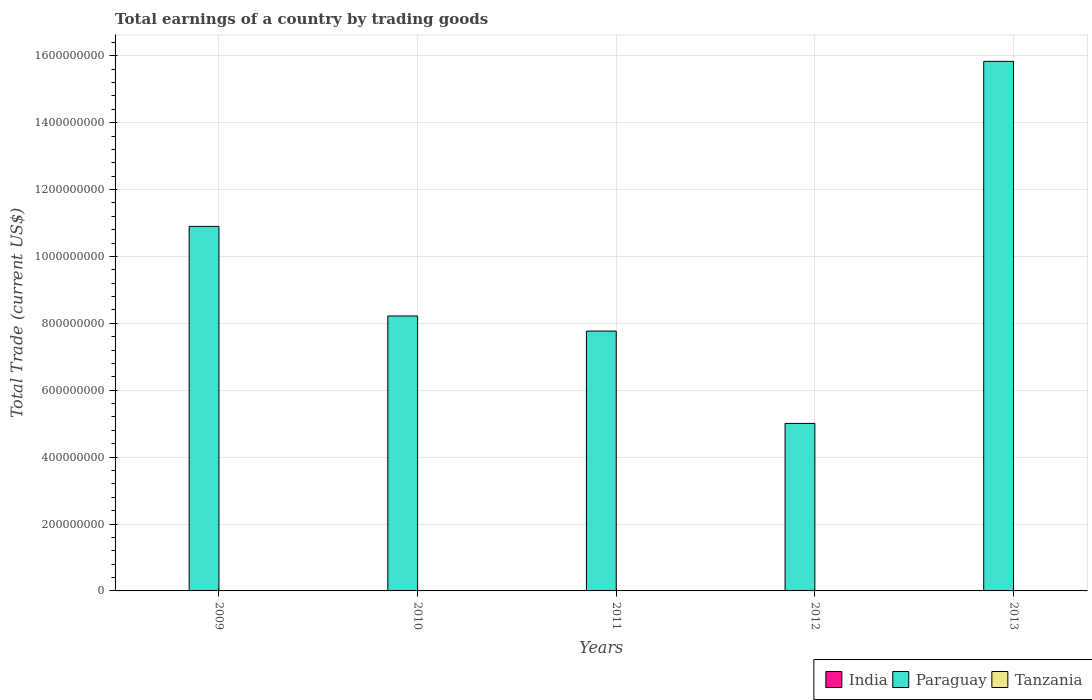How many different coloured bars are there?
Offer a terse response. 1. Are the number of bars per tick equal to the number of legend labels?
Provide a short and direct response. No. Are the number of bars on each tick of the X-axis equal?
Give a very brief answer. Yes. How many bars are there on the 3rd tick from the left?
Make the answer very short. 1. What is the total earnings in Paraguay in 2010?
Make the answer very short. 8.22e+08. Across all years, what is the minimum total earnings in Paraguay?
Your response must be concise. 5.01e+08. What is the difference between the total earnings in Paraguay in 2010 and that in 2011?
Provide a succinct answer. 4.51e+07. What is the ratio of the total earnings in Paraguay in 2011 to that in 2013?
Your answer should be compact. 0.49. What is the difference between the highest and the lowest total earnings in Paraguay?
Give a very brief answer. 1.08e+09. Is the sum of the total earnings in Paraguay in 2009 and 2010 greater than the maximum total earnings in India across all years?
Your answer should be very brief. Yes. Is it the case that in every year, the sum of the total earnings in India and total earnings in Tanzania is greater than the total earnings in Paraguay?
Offer a very short reply. No. How many bars are there?
Give a very brief answer. 5. Are all the bars in the graph horizontal?
Provide a short and direct response. No. How many years are there in the graph?
Offer a very short reply. 5. What is the difference between two consecutive major ticks on the Y-axis?
Your answer should be compact. 2.00e+08. Are the values on the major ticks of Y-axis written in scientific E-notation?
Provide a short and direct response. No. Does the graph contain any zero values?
Provide a succinct answer. Yes. Where does the legend appear in the graph?
Your answer should be very brief. Bottom right. How many legend labels are there?
Provide a succinct answer. 3. How are the legend labels stacked?
Your answer should be very brief. Horizontal. What is the title of the graph?
Provide a short and direct response. Total earnings of a country by trading goods. Does "Portugal" appear as one of the legend labels in the graph?
Provide a succinct answer. No. What is the label or title of the X-axis?
Make the answer very short. Years. What is the label or title of the Y-axis?
Your answer should be compact. Total Trade (current US$). What is the Total Trade (current US$) of Paraguay in 2009?
Provide a short and direct response. 1.09e+09. What is the Total Trade (current US$) of India in 2010?
Keep it short and to the point. 0. What is the Total Trade (current US$) of Paraguay in 2010?
Offer a terse response. 8.22e+08. What is the Total Trade (current US$) of Tanzania in 2010?
Your answer should be compact. 0. What is the Total Trade (current US$) in India in 2011?
Your answer should be very brief. 0. What is the Total Trade (current US$) of Paraguay in 2011?
Offer a terse response. 7.77e+08. What is the Total Trade (current US$) of Tanzania in 2011?
Your answer should be compact. 0. What is the Total Trade (current US$) in Paraguay in 2012?
Make the answer very short. 5.01e+08. What is the Total Trade (current US$) in Tanzania in 2012?
Offer a terse response. 0. What is the Total Trade (current US$) in Paraguay in 2013?
Give a very brief answer. 1.58e+09. Across all years, what is the maximum Total Trade (current US$) of Paraguay?
Ensure brevity in your answer.  1.58e+09. Across all years, what is the minimum Total Trade (current US$) of Paraguay?
Your answer should be compact. 5.01e+08. What is the total Total Trade (current US$) of India in the graph?
Your answer should be very brief. 0. What is the total Total Trade (current US$) of Paraguay in the graph?
Ensure brevity in your answer.  4.77e+09. What is the difference between the Total Trade (current US$) in Paraguay in 2009 and that in 2010?
Keep it short and to the point. 2.68e+08. What is the difference between the Total Trade (current US$) in Paraguay in 2009 and that in 2011?
Provide a short and direct response. 3.13e+08. What is the difference between the Total Trade (current US$) in Paraguay in 2009 and that in 2012?
Make the answer very short. 5.89e+08. What is the difference between the Total Trade (current US$) of Paraguay in 2009 and that in 2013?
Your answer should be compact. -4.93e+08. What is the difference between the Total Trade (current US$) in Paraguay in 2010 and that in 2011?
Offer a very short reply. 4.51e+07. What is the difference between the Total Trade (current US$) of Paraguay in 2010 and that in 2012?
Make the answer very short. 3.21e+08. What is the difference between the Total Trade (current US$) of Paraguay in 2010 and that in 2013?
Ensure brevity in your answer.  -7.61e+08. What is the difference between the Total Trade (current US$) in Paraguay in 2011 and that in 2012?
Ensure brevity in your answer.  2.76e+08. What is the difference between the Total Trade (current US$) in Paraguay in 2011 and that in 2013?
Make the answer very short. -8.06e+08. What is the difference between the Total Trade (current US$) in Paraguay in 2012 and that in 2013?
Keep it short and to the point. -1.08e+09. What is the average Total Trade (current US$) in India per year?
Ensure brevity in your answer.  0. What is the average Total Trade (current US$) of Paraguay per year?
Ensure brevity in your answer.  9.55e+08. What is the average Total Trade (current US$) in Tanzania per year?
Provide a short and direct response. 0. What is the ratio of the Total Trade (current US$) in Paraguay in 2009 to that in 2010?
Provide a succinct answer. 1.33. What is the ratio of the Total Trade (current US$) in Paraguay in 2009 to that in 2011?
Your answer should be very brief. 1.4. What is the ratio of the Total Trade (current US$) in Paraguay in 2009 to that in 2012?
Offer a terse response. 2.18. What is the ratio of the Total Trade (current US$) of Paraguay in 2009 to that in 2013?
Give a very brief answer. 0.69. What is the ratio of the Total Trade (current US$) of Paraguay in 2010 to that in 2011?
Offer a very short reply. 1.06. What is the ratio of the Total Trade (current US$) of Paraguay in 2010 to that in 2012?
Provide a succinct answer. 1.64. What is the ratio of the Total Trade (current US$) of Paraguay in 2010 to that in 2013?
Provide a succinct answer. 0.52. What is the ratio of the Total Trade (current US$) of Paraguay in 2011 to that in 2012?
Provide a succinct answer. 1.55. What is the ratio of the Total Trade (current US$) in Paraguay in 2011 to that in 2013?
Ensure brevity in your answer.  0.49. What is the ratio of the Total Trade (current US$) in Paraguay in 2012 to that in 2013?
Your answer should be very brief. 0.32. What is the difference between the highest and the second highest Total Trade (current US$) in Paraguay?
Offer a terse response. 4.93e+08. What is the difference between the highest and the lowest Total Trade (current US$) of Paraguay?
Keep it short and to the point. 1.08e+09. 